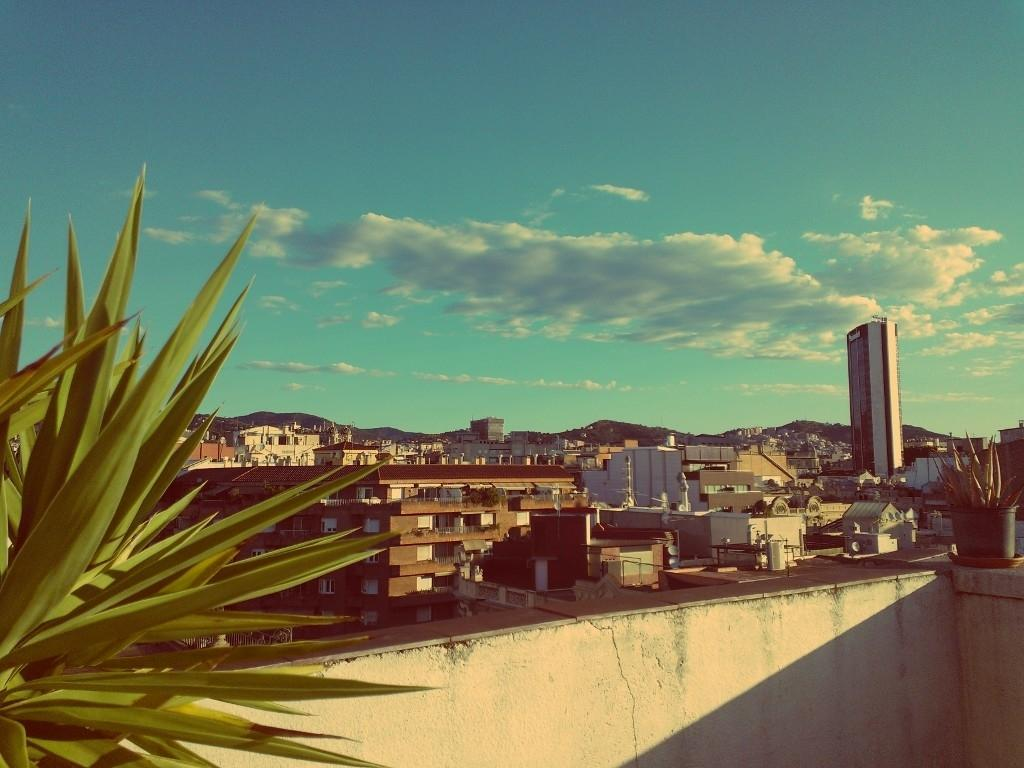What is located in the center of the image? There are buildings in the center of the image. What type of vegetation can be seen on the right side of the image? There are plants on the right side of the image. What type of vegetation can be seen on the left side of the image? There are plants on the left side of the image. What is visible at the top of the image? The sky is visible at the top of the image. How does the payment system work for the plants in the image? There is no payment system present in the image, as it features buildings, plants, and the sky. Can you describe the net used to catch the birds in the image? There are no birds or nets present in the image; it features buildings, plants, and the sky. 